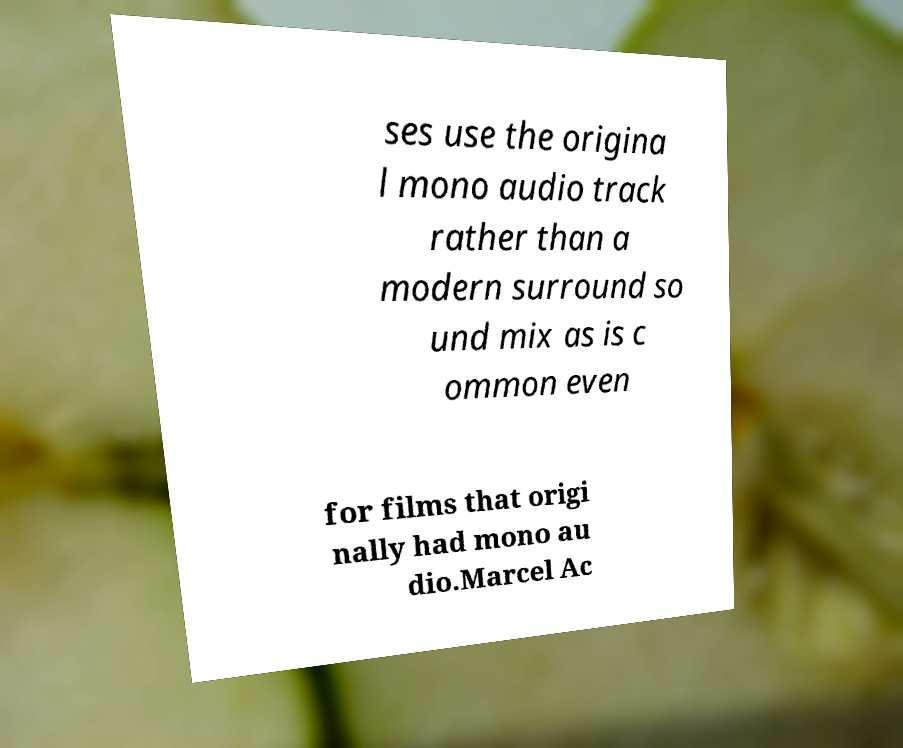Can you read and provide the text displayed in the image?This photo seems to have some interesting text. Can you extract and type it out for me? ses use the origina l mono audio track rather than a modern surround so und mix as is c ommon even for films that origi nally had mono au dio.Marcel Ac 